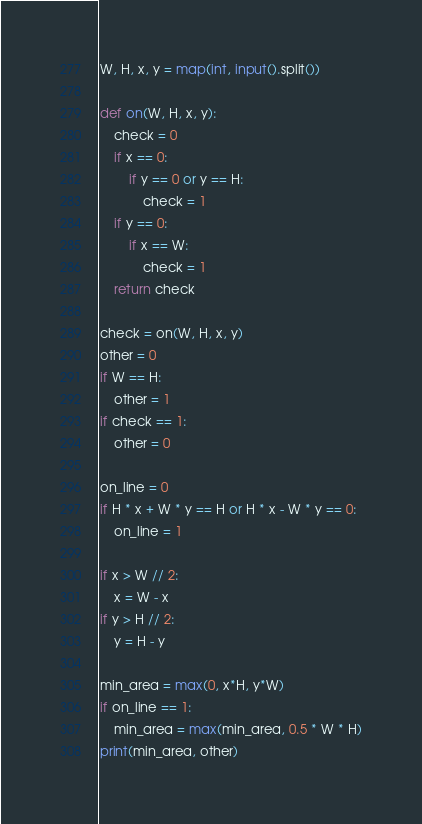<code> <loc_0><loc_0><loc_500><loc_500><_Python_>W, H, x, y = map(int, input().split())

def on(W, H, x, y):
    check = 0
    if x == 0:
        if y == 0 or y == H:
            check = 1
    if y == 0:
        if x == W:
            check = 1
    return check

check = on(W, H, x, y)
other = 0
if W == H:
    other = 1
if check == 1:
    other = 0

on_line = 0
if H * x + W * y == H or H * x - W * y == 0:
    on_line = 1
    
if x > W // 2:
    x = W - x
if y > H // 2:
    y = H - y

min_area = max(0, x*H, y*W)
if on_line == 1:
    min_area = max(min_area, 0.5 * W * H)
print(min_area, other)
</code> 